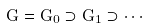<formula> <loc_0><loc_0><loc_500><loc_500>G = G _ { 0 } \supset G _ { 1 } \supset \cdots</formula> 